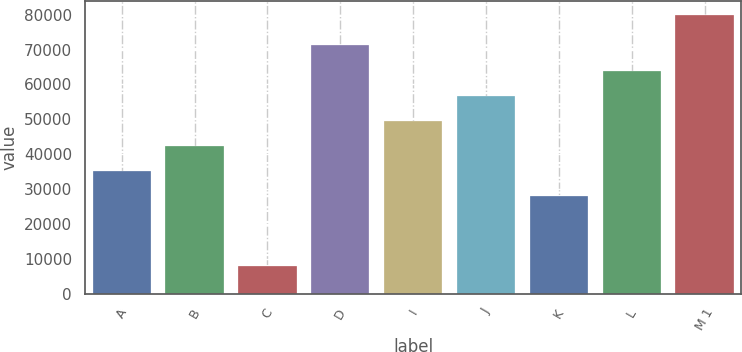Convert chart to OTSL. <chart><loc_0><loc_0><loc_500><loc_500><bar_chart><fcel>A<fcel>B<fcel>C<fcel>D<fcel>I<fcel>J<fcel>K<fcel>L<fcel>M 1<nl><fcel>35200<fcel>42400<fcel>8000<fcel>71200<fcel>49600<fcel>56800<fcel>28000<fcel>64000<fcel>80000<nl></chart> 